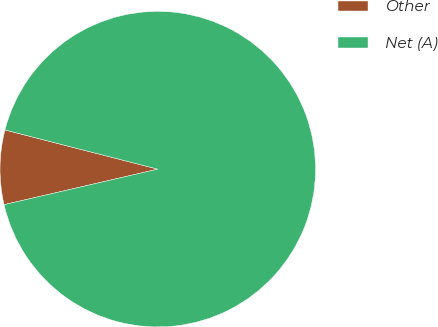<chart> <loc_0><loc_0><loc_500><loc_500><pie_chart><fcel>Other<fcel>Net (A)<nl><fcel>7.61%<fcel>92.39%<nl></chart> 